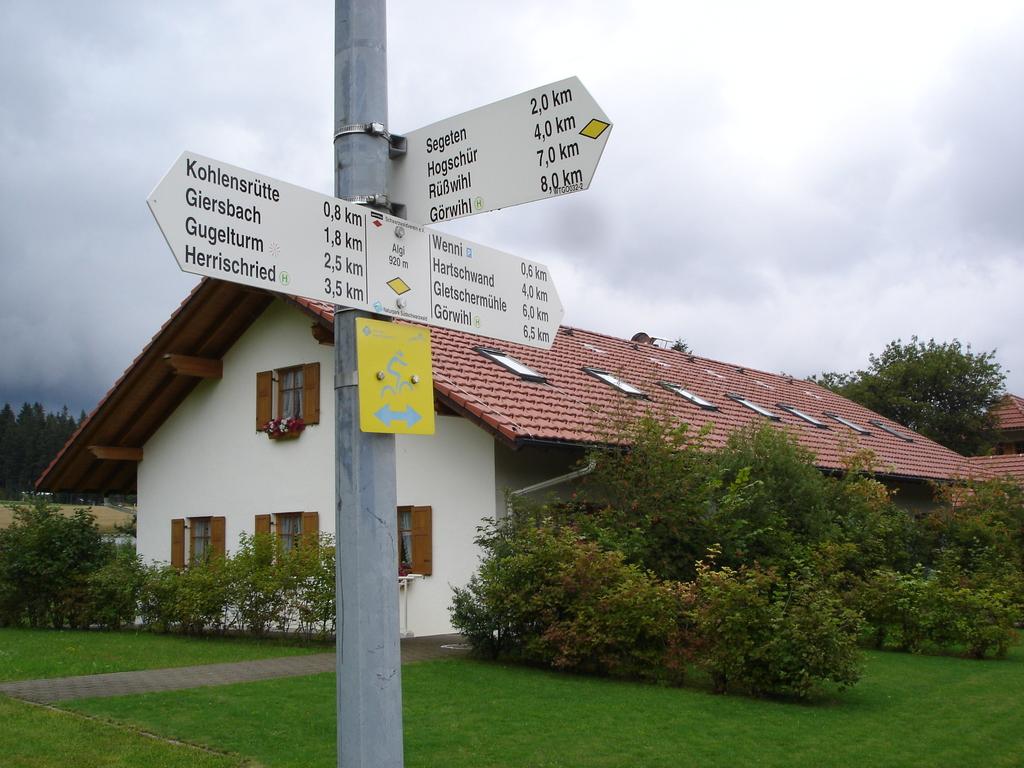Which place is 2.0km away?
Your answer should be very brief. Segeten. What place is 0.8 km away?
Make the answer very short. Kohlensrutte. 